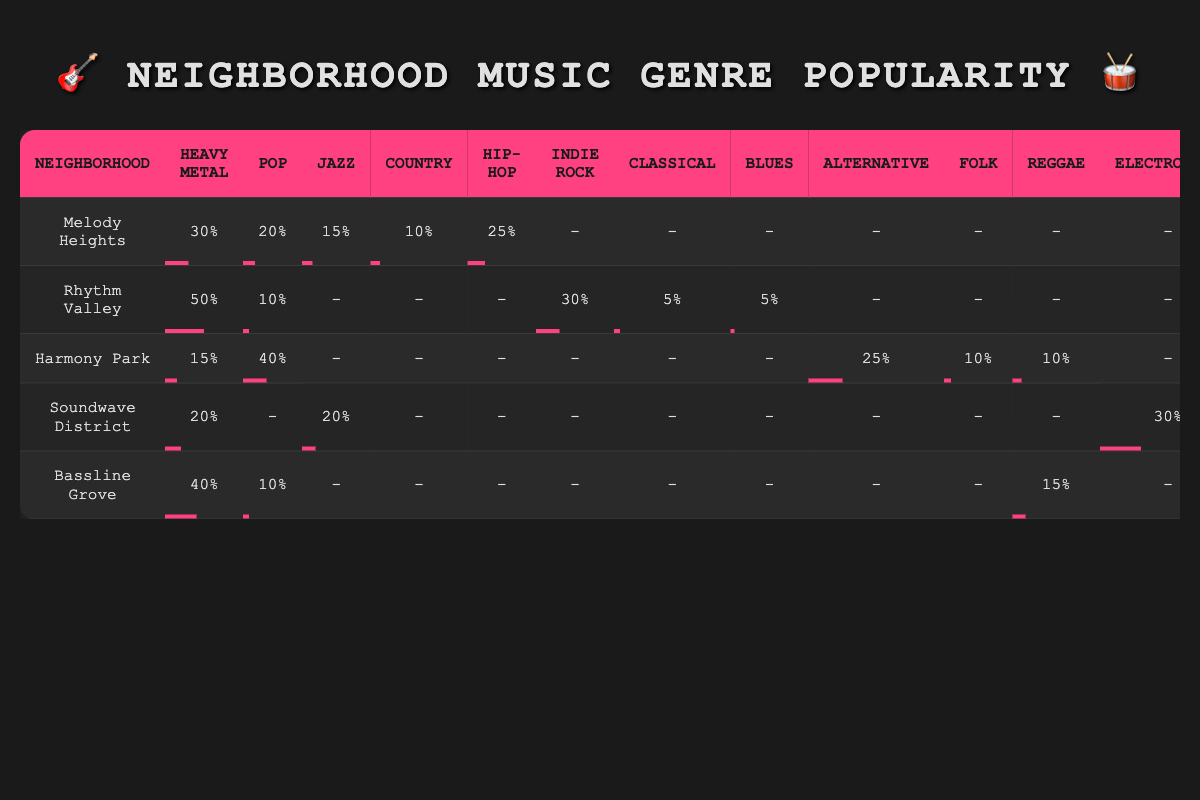What neighborhood has the highest Heavy Metal popularity? In the table, Rhythm Valley has the highest percentage of Heavy Metal popularity at 50%.
Answer: Rhythm Valley Which neighborhood has the least popularity for Pop music? By checking the Pop music column, Rhythm Valley shows the lowest percentage of 10%, making it the neighborhood with the least popularity for Pop.
Answer: Rhythm Valley What is the total Heavy Metal popularity across all neighborhoods? Adding up the Heavy Metal percentages from all neighborhoods: 30 + 50 + 15 + 20 + 40 = 155%.
Answer: 155% Is there a neighborhood where Jazz is more popular than Electronica? Looking at the table, Soundwave District has 20% for Jazz and 30% for Electronica. Since Jazz is less popular than Electronica in this neighborhood, the answer is no.
Answer: No Which neighborhood has the highest overall percentage of Jazz music popularity? Examining the Jazz popularity column, both Soundwave District and Harmony Park have a value of 20%, which is the highest.
Answer: Soundwave District and Harmony Park What is the average popularity of Heavy Metal across the neighborhoods? To find the average, you sum the Heavy Metal percentages: 30 + 50 + 15 + 20 + 40 = 155, then divide by 5 (the number of neighborhoods), resulting in 155 / 5 = 31%.
Answer: 31% Is there any neighborhood where Reggae is more popular than Country music? By comparing the Reggae and Country percentages across neighborhoods: Bassline Grove has Reggae at 15% and Country is unfound, while others have similar or lower. Thus Bassline Grove has least popularity.
Answer: No What percentage value does Melody Heights have for Hip-Hop? Looking at Melody Heights, the Hip-Hop popularity percentage is listed as 25%.
Answer: 25% In how many neighborhoods is Pop music less popular than Heavy Metal? By comparing the Pop percentages to Heavy Metal across neighborhoods, Melody Heights, Harmony Park, and Soundwave District have Pop less popular than Heavy Metal. That totals three neighborhoods.
Answer: 3 